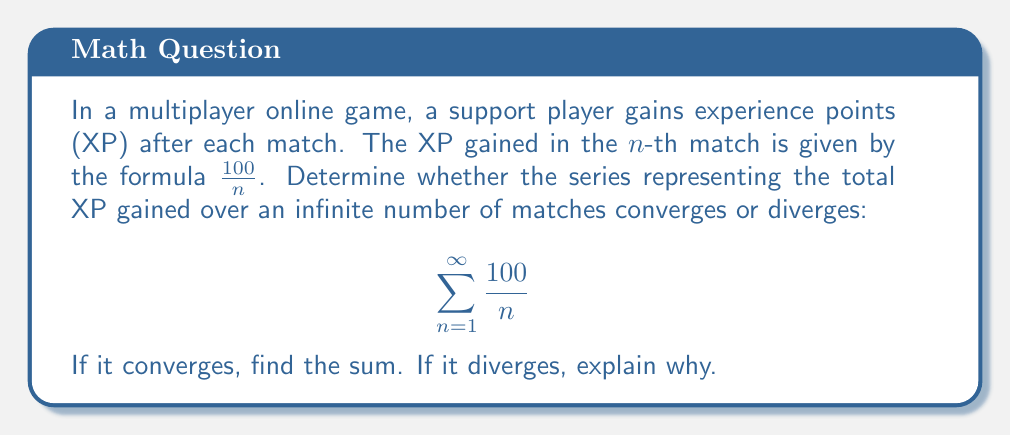Can you answer this question? To determine the convergence or divergence of this series, we can use the p-series test:

1) First, we recognize that this series is in the form of a p-series:

   $$ \sum_{n=1}^{\infty} \frac{100}{n} = 100 \sum_{n=1}^{\infty} \frac{1}{n} $$

2) For a p-series $\sum_{n=1}^{\infty} \frac{1}{n^p}$:
   - If $p > 1$, the series converges
   - If $p \leq 1$, the series diverges

3) In our case, $p = 1$, so $p \leq 1$

4) Therefore, the series $\sum_{n=1}^{\infty} \frac{1}{n}$ diverges

5) Since our original series is just a constant multiple (100) of a divergent series, it also diverges

The divergence of this series makes sense in the context of the game. It means that as the player continues to play an infinite number of matches, their total XP will grow without bound, even though the XP gained per match decreases over time.

This reflects the nature of many games where players can always continue to accumulate experience, albeit at a slower rate as they progress.
Answer: The series diverges. The total XP gained over an infinite number of matches is unbounded. 